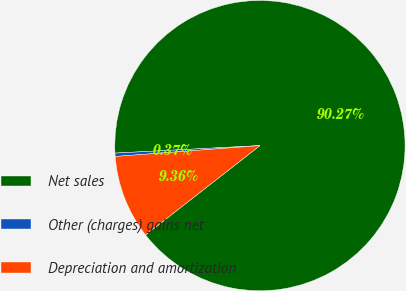<chart> <loc_0><loc_0><loc_500><loc_500><pie_chart><fcel>Net sales<fcel>Other (charges) gains net<fcel>Depreciation and amortization<nl><fcel>90.27%<fcel>0.37%<fcel>9.36%<nl></chart> 